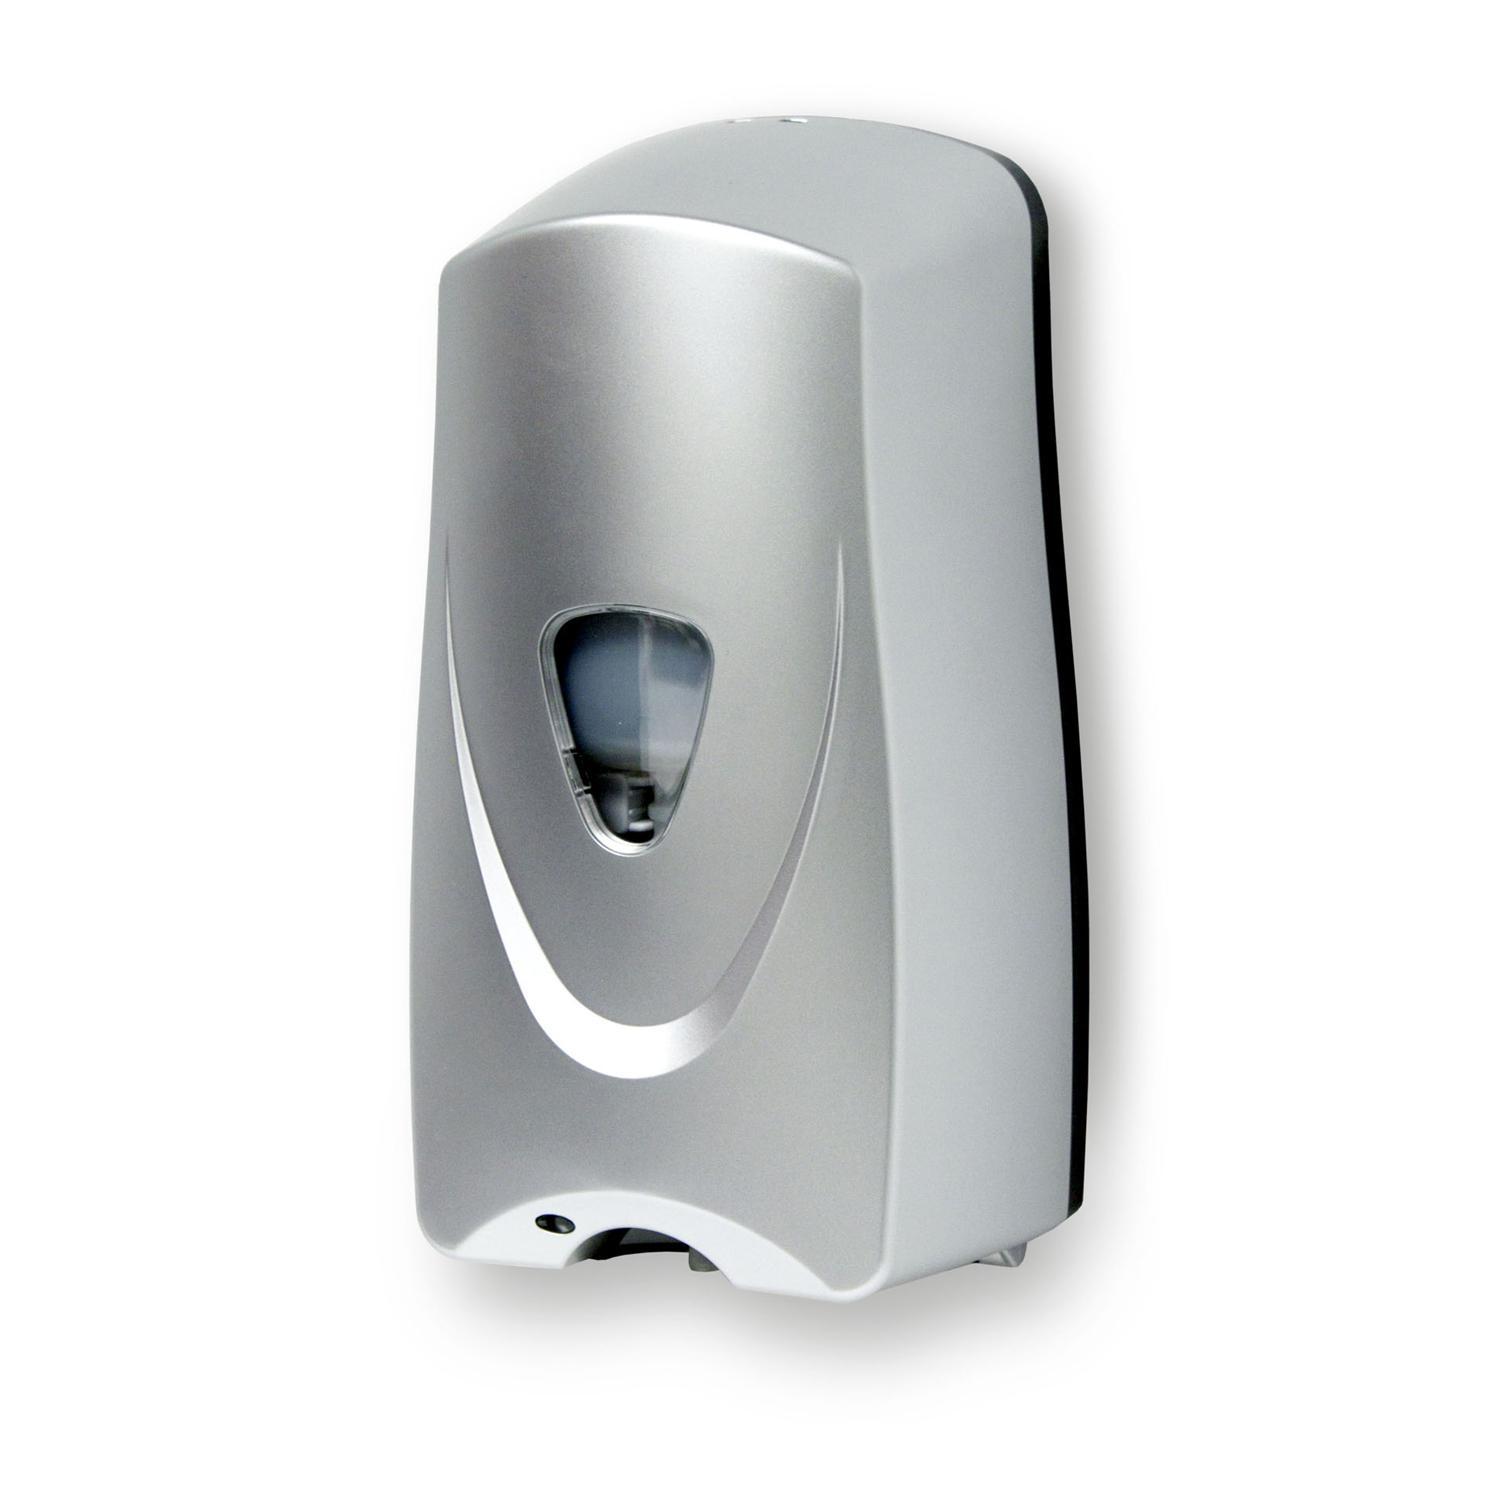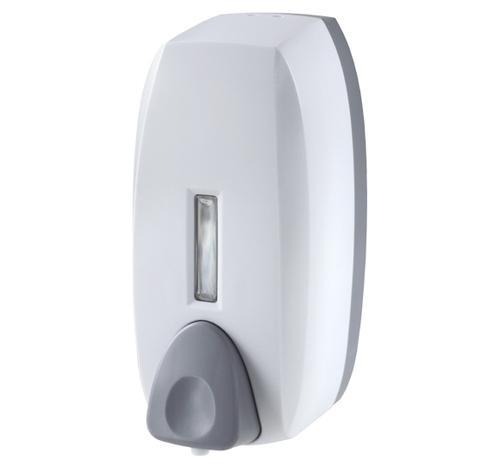The first image is the image on the left, the second image is the image on the right. For the images shown, is this caption "The dispenser in the image on the right has a gray button." true? Answer yes or no. Yes. 